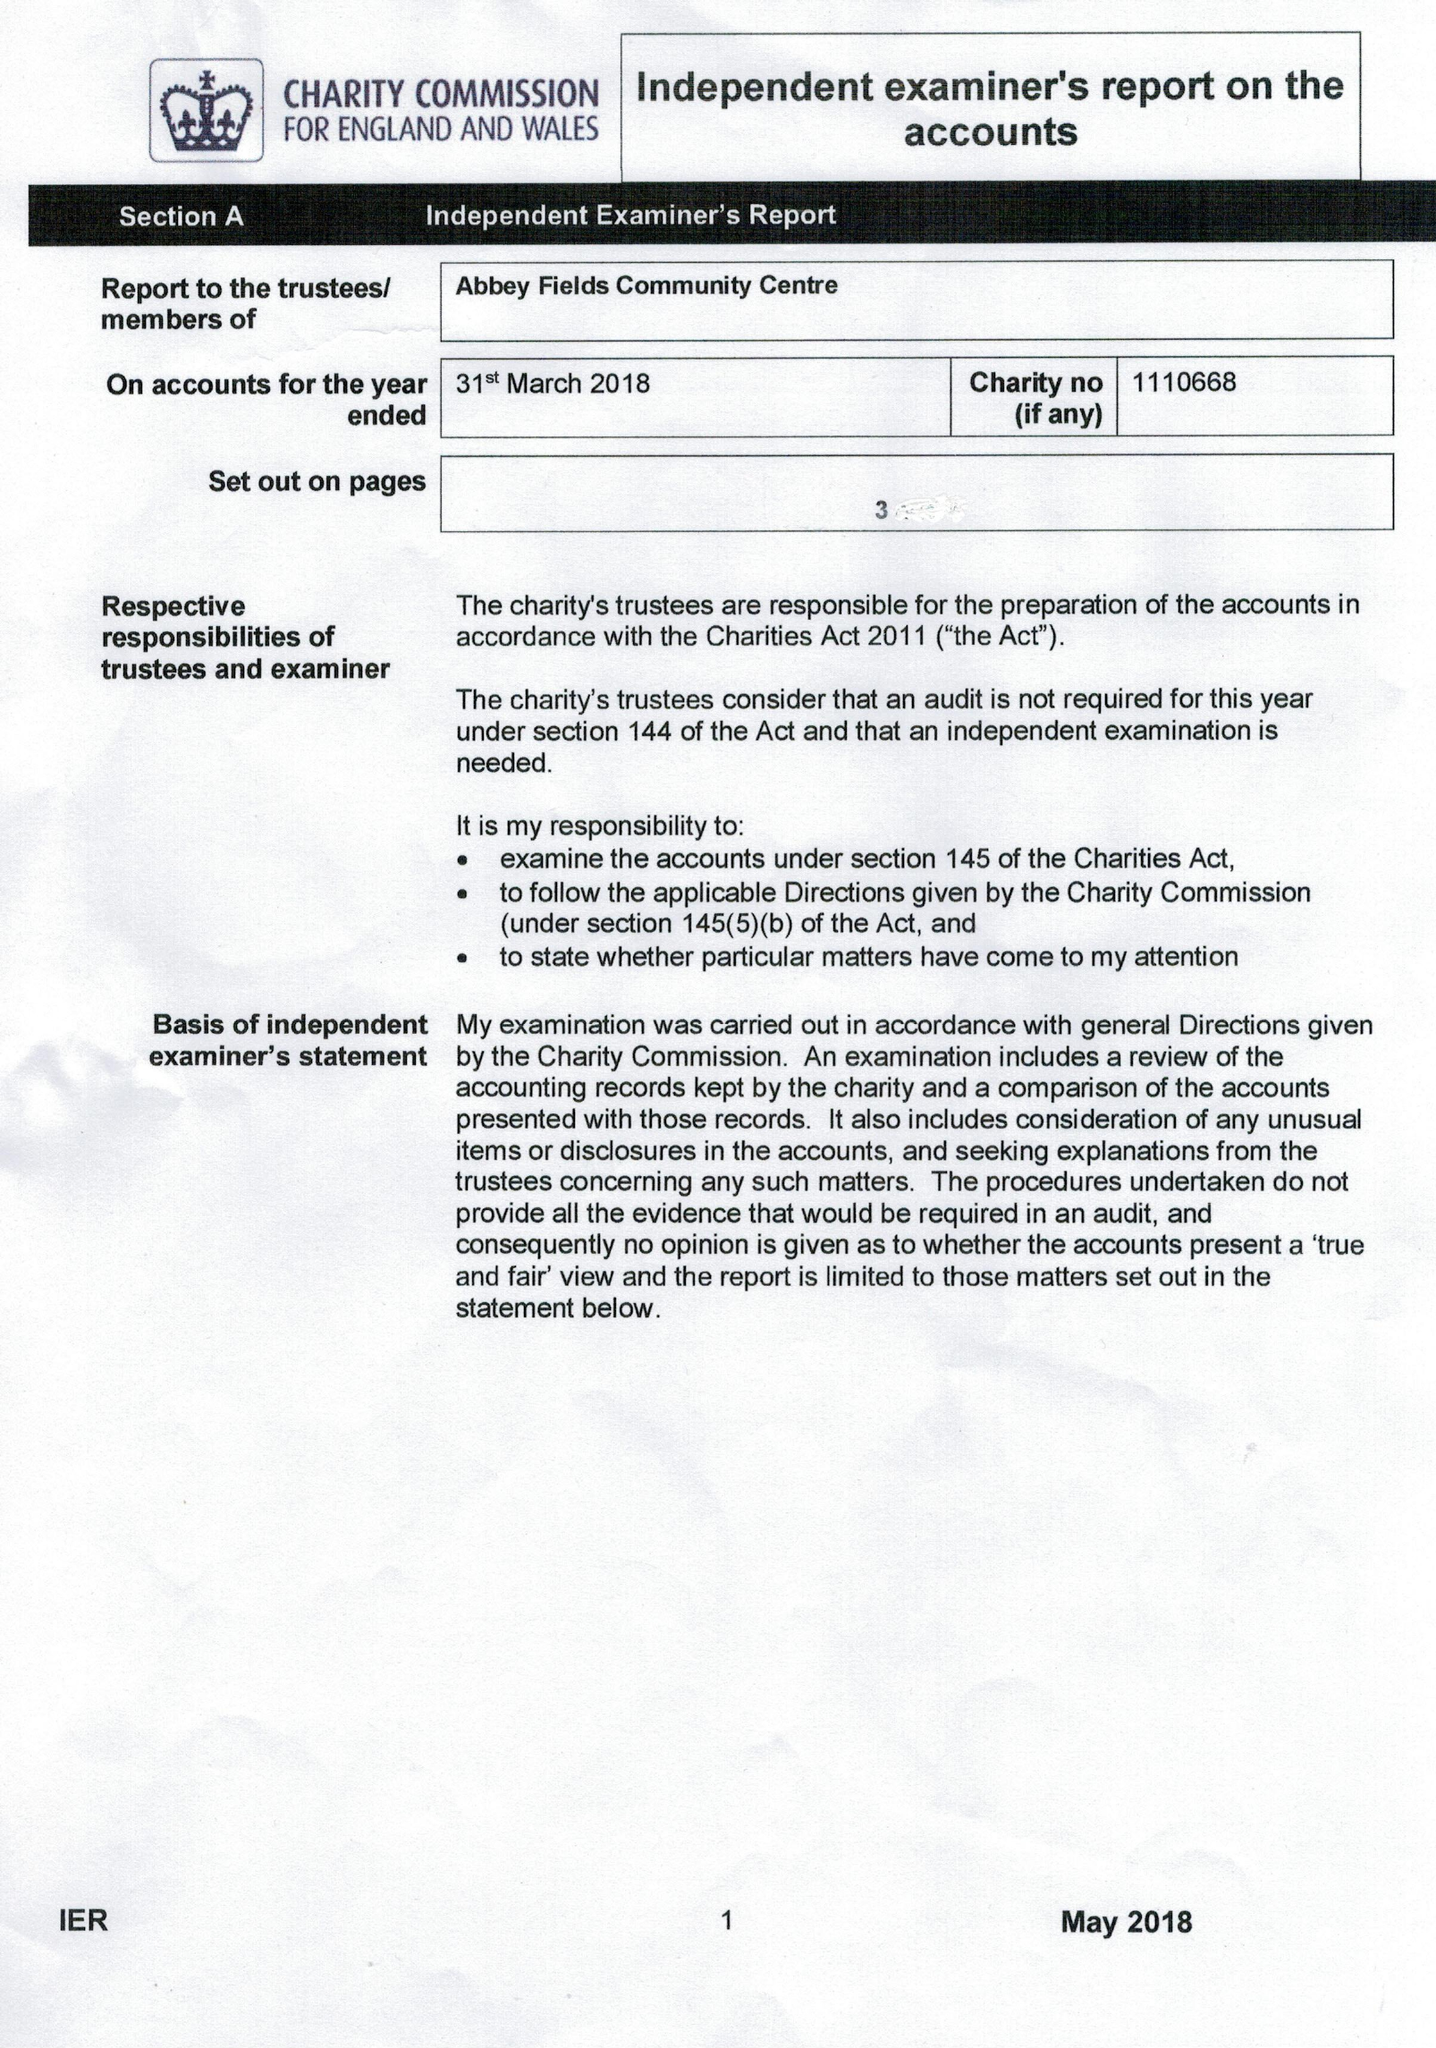What is the value for the address__street_line?
Answer the question using a single word or phrase. BACK LANE 